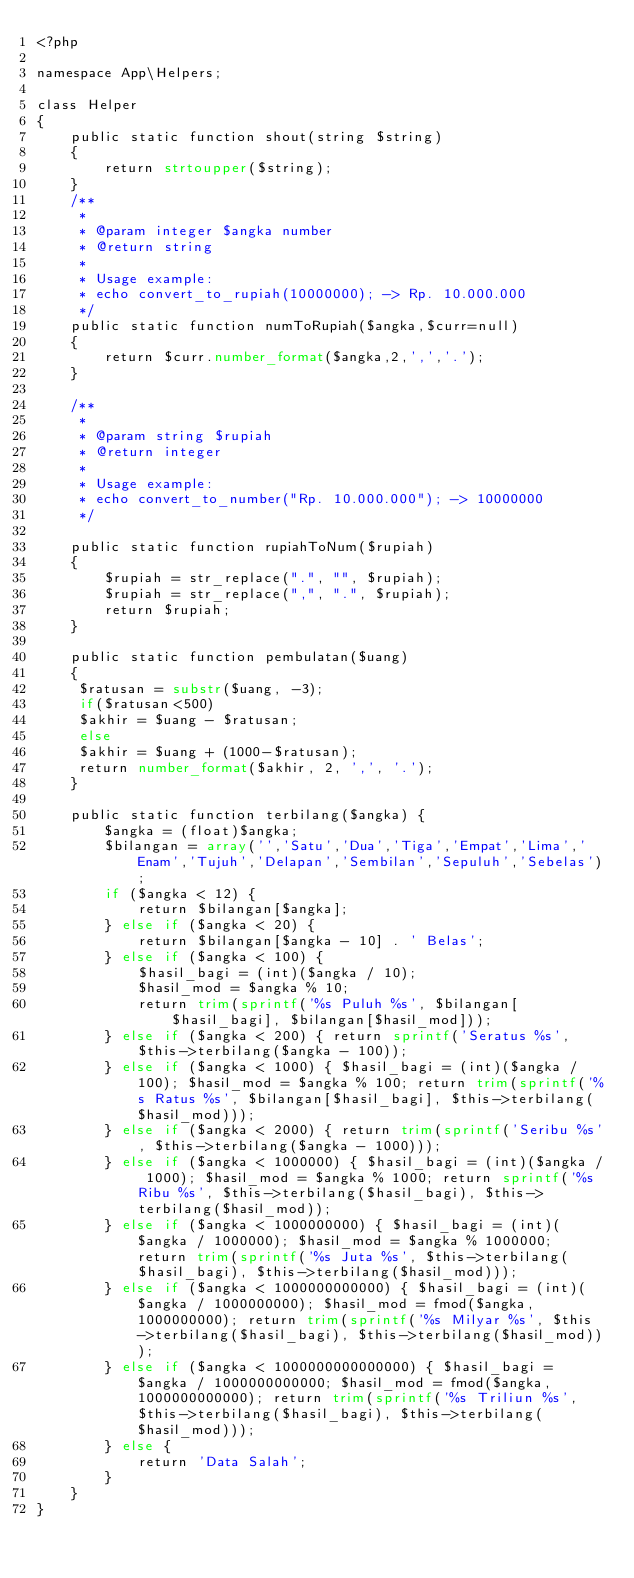<code> <loc_0><loc_0><loc_500><loc_500><_PHP_><?php

namespace App\Helpers;

class Helper
{
    public static function shout(string $string)
    {
        return strtoupper($string);
    }
    /**	 
	 *
	 * @param integer $angka number
	 * @return string
	 *
	 * Usage example:
	 * echo convert_to_rupiah(10000000); -> Rp. 10.000.000	 
	 */ 
	public static function numToRupiah($angka,$curr=null)
	{
		return $curr.number_format($angka,2,',','.');
	}
	
	/**
	 *
	 * @param string $rupiah
	 * @return integer
	 *
	 * Usage example:
	 * echo convert_to_number("Rp. 10.000.000"); -> 10000000
	 */	
	 
	public static function rupiahToNum($rupiah)
	{
		$rupiah = str_replace(".", "", $rupiah);
		$rupiah = str_replace(",", ".", $rupiah);
		return $rupiah;
	}

	public static function pembulatan($uang)
	{
	 $ratusan = substr($uang, -3);
	 if($ratusan<500)
	 $akhir = $uang - $ratusan;
	 else
	 $akhir = $uang + (1000-$ratusan);
	 return number_format($akhir, 2, ',', '.');
	}

    public static function terbilang($angka) {
        $angka = (float)$angka;
        $bilangan = array('','Satu','Dua','Tiga','Empat','Lima','Enam','Tujuh','Delapan','Sembilan','Sepuluh','Sebelas');
        if ($angka < 12) {
            return $bilangan[$angka];
        } else if ($angka < 20) {
            return $bilangan[$angka - 10] . ' Belas';
        } else if ($angka < 100) {
            $hasil_bagi = (int)($angka / 10);
            $hasil_mod = $angka % 10;
            return trim(sprintf('%s Puluh %s', $bilangan[$hasil_bagi], $bilangan[$hasil_mod]));
        } else if ($angka < 200) { return sprintf('Seratus %s', $this->terbilang($angka - 100));
        } else if ($angka < 1000) { $hasil_bagi = (int)($angka / 100); $hasil_mod = $angka % 100; return trim(sprintf('%s Ratus %s', $bilangan[$hasil_bagi], $this->terbilang($hasil_mod)));
        } else if ($angka < 2000) { return trim(sprintf('Seribu %s', $this->terbilang($angka - 1000)));
        } else if ($angka < 1000000) { $hasil_bagi = (int)($angka / 1000); $hasil_mod = $angka % 1000; return sprintf('%s Ribu %s', $this->terbilang($hasil_bagi), $this->terbilang($hasil_mod));
        } else if ($angka < 1000000000) { $hasil_bagi = (int)($angka / 1000000); $hasil_mod = $angka % 1000000; return trim(sprintf('%s Juta %s', $this->terbilang($hasil_bagi), $this->terbilang($hasil_mod)));
        } else if ($angka < 1000000000000) { $hasil_bagi = (int)($angka / 1000000000); $hasil_mod = fmod($angka, 1000000000); return trim(sprintf('%s Milyar %s', $this->terbilang($hasil_bagi), $this->terbilang($hasil_mod)));
        } else if ($angka < 1000000000000000) { $hasil_bagi = $angka / 1000000000000; $hasil_mod = fmod($angka, 1000000000000); return trim(sprintf('%s Triliun %s', $this->terbilang($hasil_bagi), $this->terbilang($hasil_mod)));
        } else {
            return 'Data Salah';
        }
    }
}</code> 